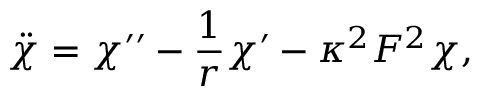<formula> <loc_0><loc_0><loc_500><loc_500>\ddot { \chi } = \chi \prime \prime - \frac { 1 } { r } \chi \prime - \kappa ^ { 2 } F ^ { 2 } \chi ,</formula> 